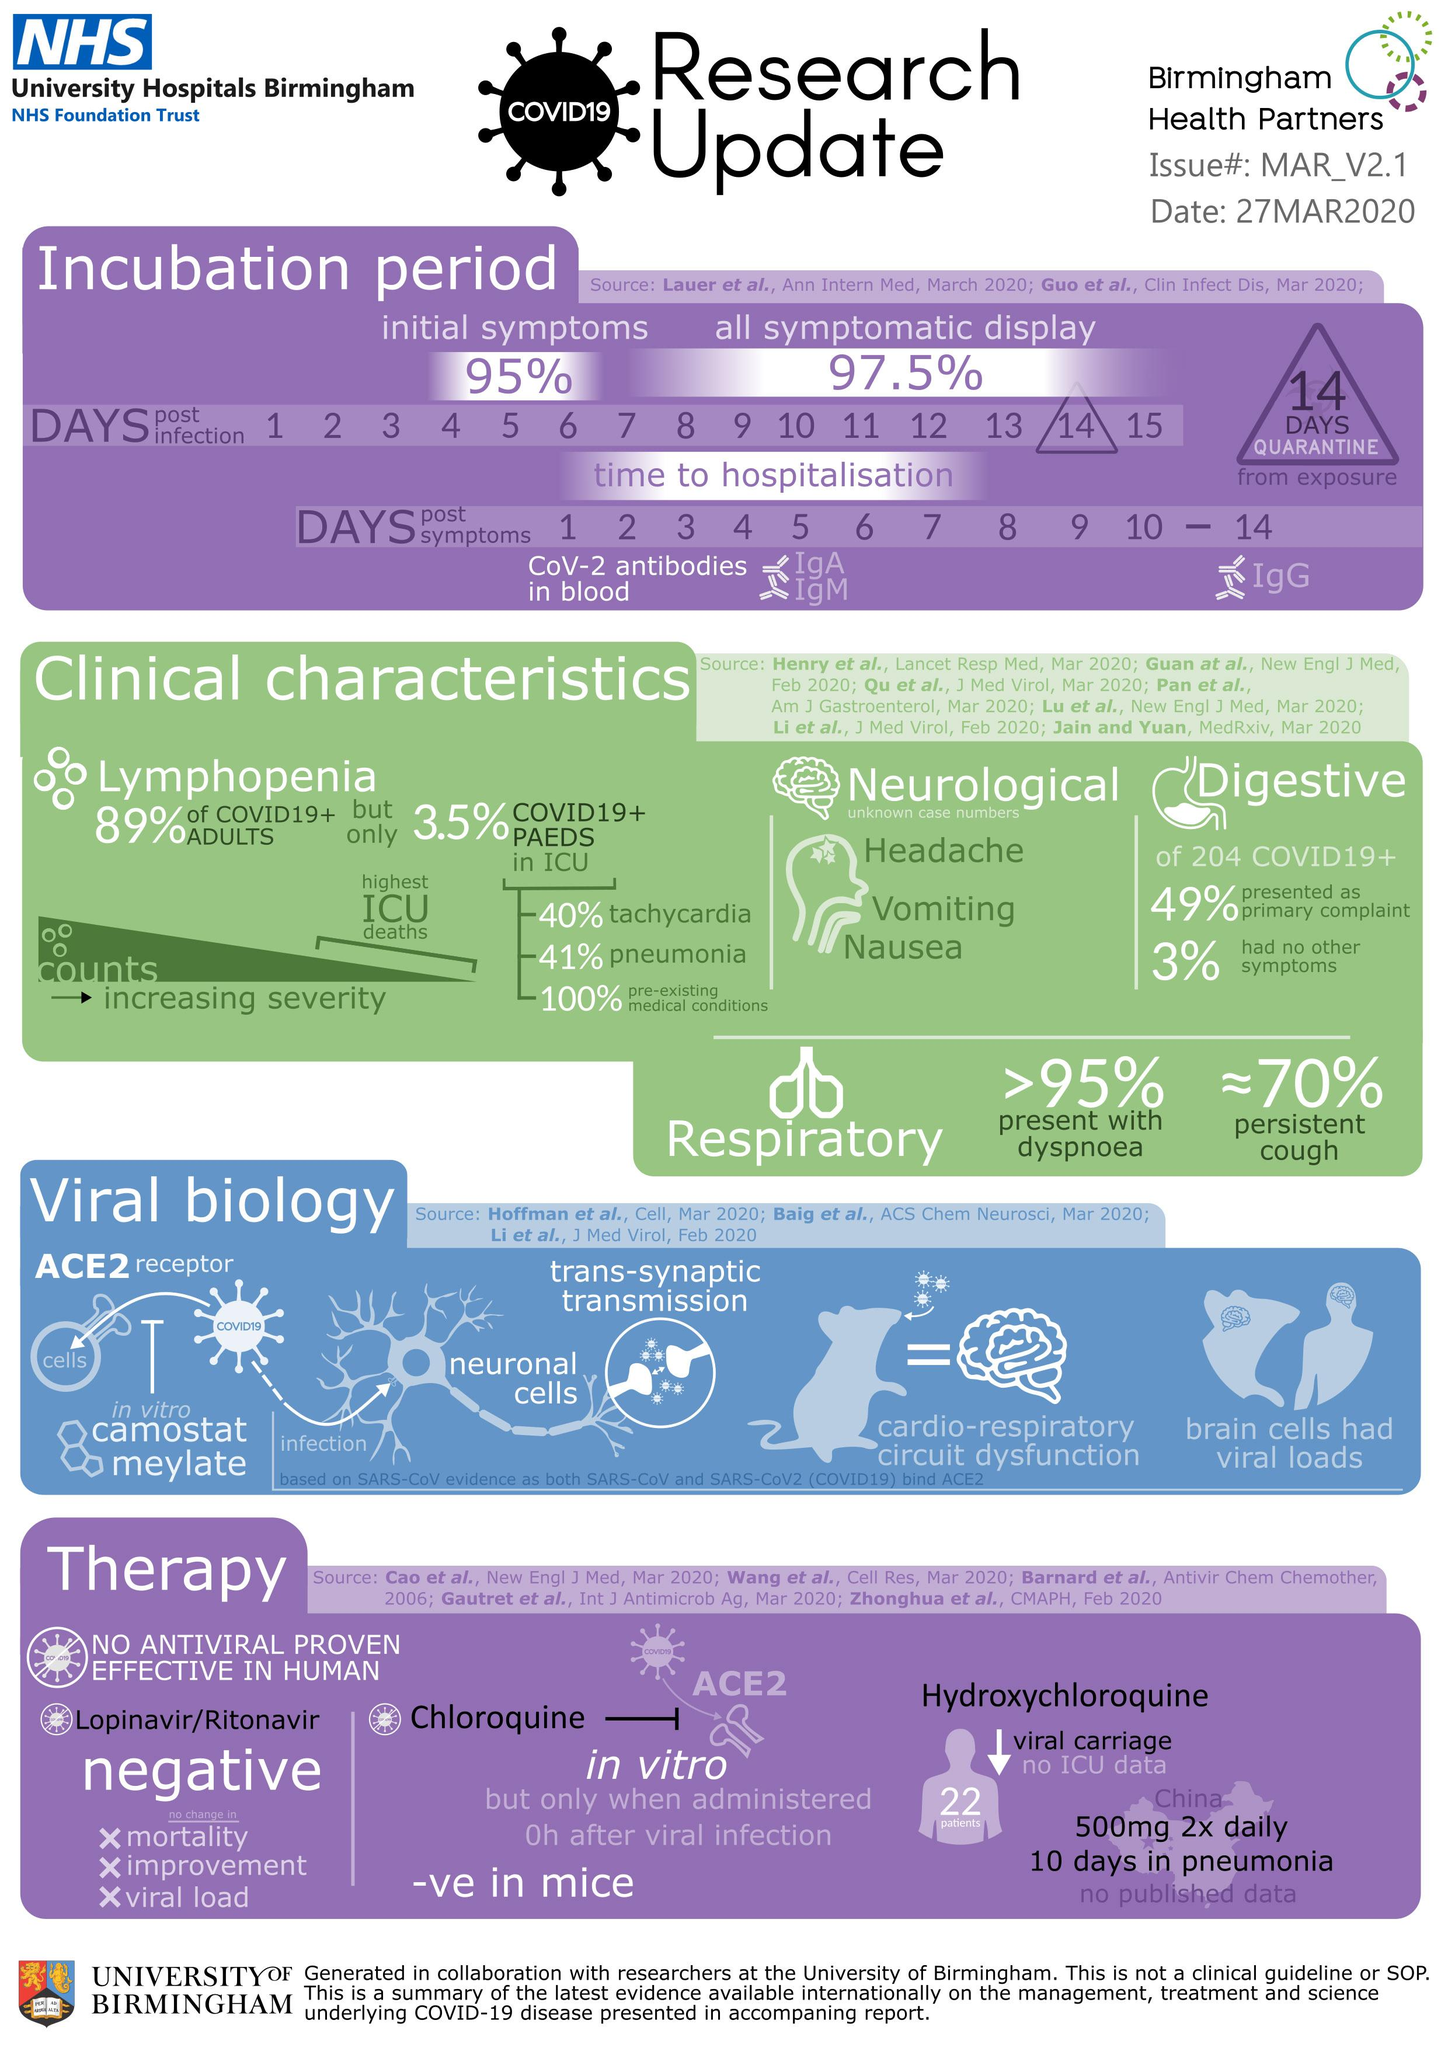Specify some key components in this picture. Approximately 49% of the 204 COVID-19 cases reported to have digestive problems as their primary complaint. According to the data, out of 204 COVID-19 positive cases, 3% did not exhibit any other symptoms. It is mandatory to undergo a 14-day quarantine period after exposure to the Covid-19 virus. According to recent data, more than 95% of COVID-19 positive cases experience dyspnoea. According to recent data, approximately 70% of COVID-19 cases have experienced a persistent cough. 